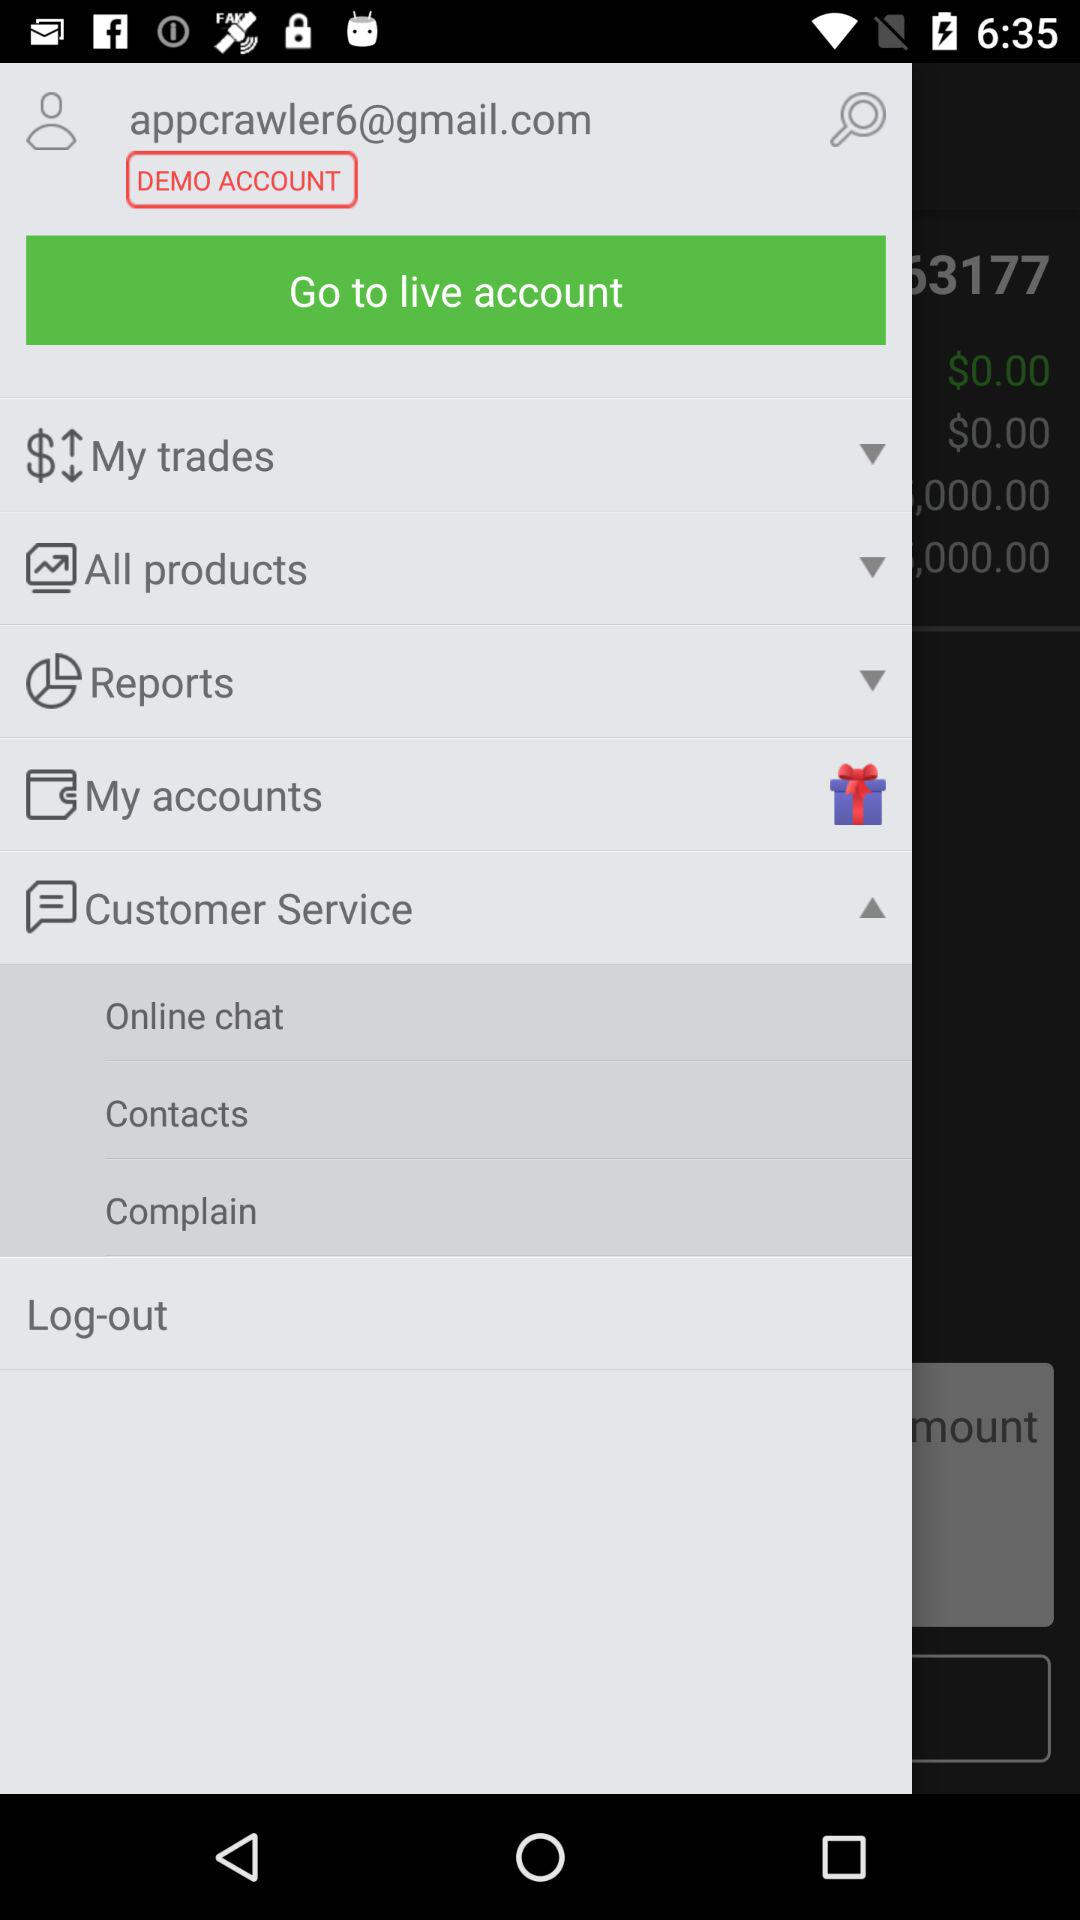What is the email address of the demo account? The email address of the demo account is appcrawler6@gmail.com. 